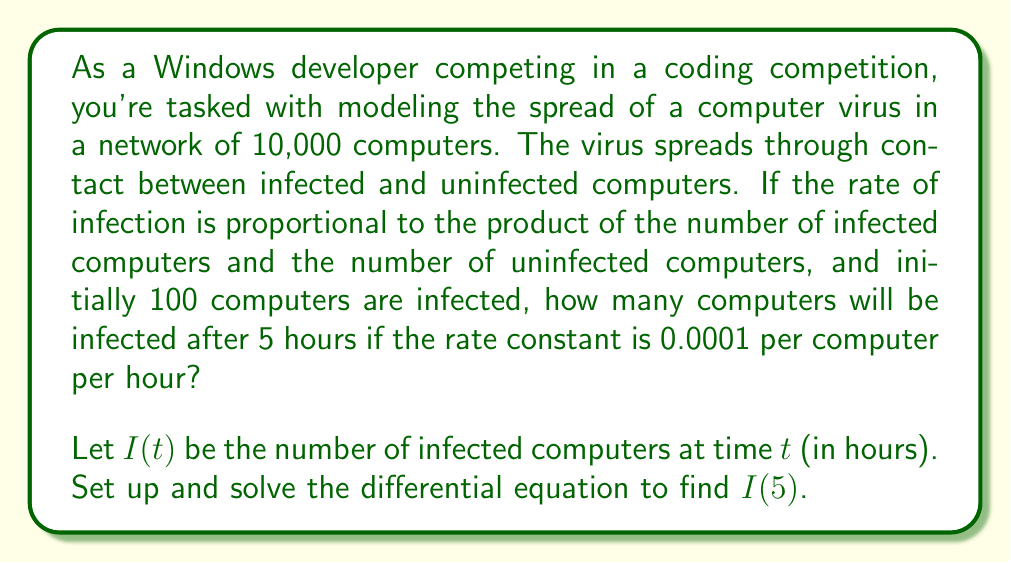Show me your answer to this math problem. Let's approach this step-by-step:

1) First, we need to set up the differential equation. The rate of change of infected computers is proportional to the product of infected and uninfected computers:

   $$\frac{dI}{dt} = kI(N-I)$$

   where $k$ is the rate constant, $N$ is the total number of computers, and $(N-I)$ represents the number of uninfected computers.

2) We're given:
   - $N = 10,000$ (total computers)
   - $k = 0.0001$ per computer per hour
   - $I(0) = 100$ (initial infected computers)

3) Substituting these values, our differential equation becomes:

   $$\frac{dI}{dt} = 0.0001I(10000-I)$$

4) This is a separable differential equation. Let's separate the variables:

   $$\frac{dI}{I(10000-I)} = 0.0001dt$$

5) Integrating both sides:

   $$\int\frac{dI}{I(10000-I)} = \int0.0001dt$$

6) The left side can be integrated using partial fractions:

   $$\frac{1}{10000}\ln\left|\frac{I}{10000-I}\right| = 0.0001t + C$$

7) Using the initial condition $I(0) = 100$, we can solve for $C$:

   $$\frac{1}{10000}\ln\left|\frac{100}{9900}\right| = C$$

8) Now we can write the general solution:

   $$\frac{1}{10000}\ln\left|\frac{I}{10000-I}\right| = 0.0001t + \frac{1}{10000}\ln\left|\frac{100}{9900}\right|$$

9) Simplifying and solving for $I$:

   $$I = \frac{10000}{1 + 99e^{-t}}$$

10) To find $I(5)$, we substitute $t = 5$:

    $$I(5) = \frac{10000}{1 + 99e^{-5}} \approx 9272.45$$
Answer: After 5 hours, approximately 9,272 computers will be infected. 